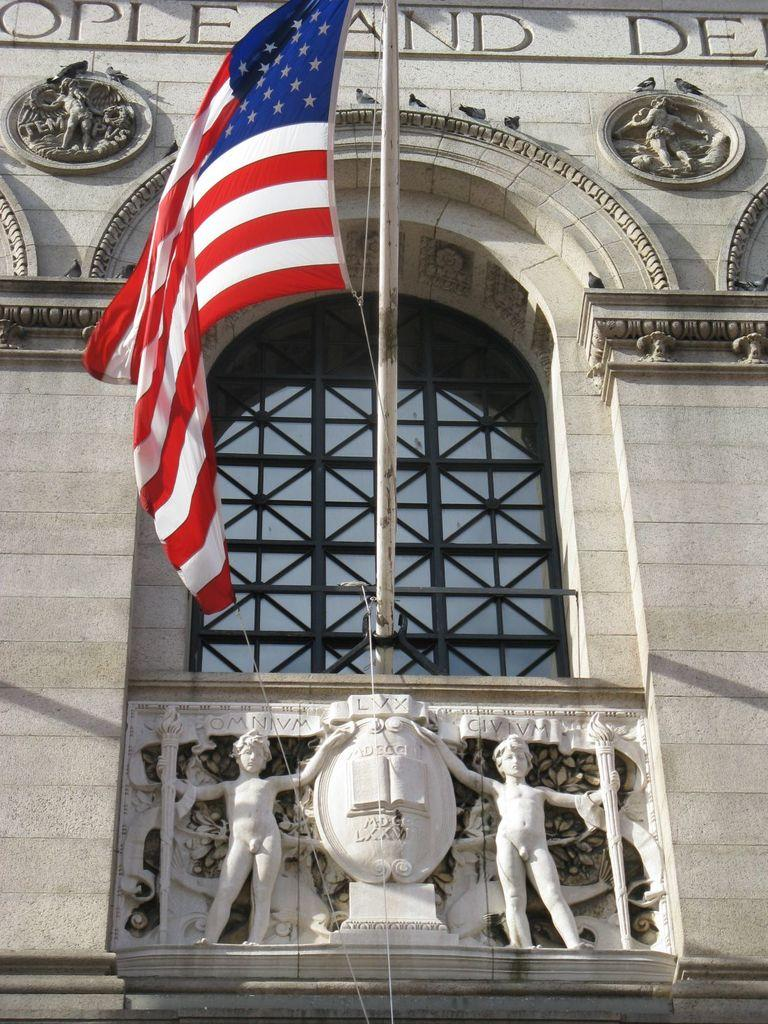Where was the image taken from? The image was taken from outside of a building. What can be seen in the middle of the image? There is a pole in the middle of the image, and a flag is present on the pole. What other objects are in the middle of the image? There are sculptures in the middle of the image. What can be seen in the background of the image? There is a building and a glass window visible in the background of the image. How many volleyballs can be seen on the sculptures in the image? There are no volleyballs present in the image; the sculptures do not depict any sports equipment. 